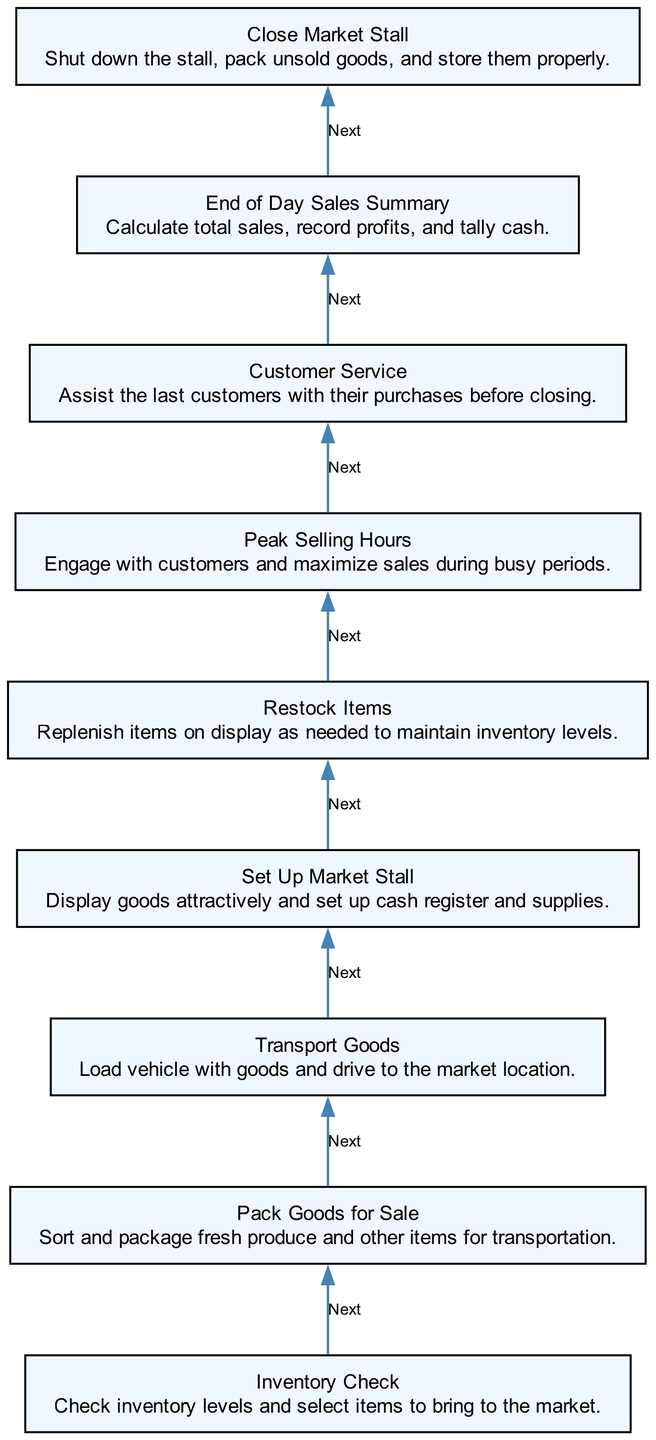What is the first step in the sales process? The flowchart indicates that the first step when starting the sales process is "Inventory Check," which involves checking inventory levels and selecting items to bring to the market.
Answer: Inventory Check How many steps are there in the process? By counting each listed step in the flowchart, there are a total of nine distinct steps involved in the weekend market sales process.
Answer: Nine What step comes after "Transport Goods"? The diagram shows that the step following "Transport Goods" is "Set Up Market Stall." It directly connects as the next action after loading goods for transport.
Answer: Set Up Market Stall Which step involves maximizing sales during busy periods? The step named "Peak Selling Hours" is specifically focused on engaging with customers to maximize sales during those busy times at the market.
Answer: Peak Selling Hours What happens immediately before "End of Day Sales Summary"? "Customer Service" precedes "End of Day Sales Summary," as indicated by the flow from one step to the next in the diagram.
Answer: Customer Service What is the last step in the weekend market sales process? The final step in the flowchart is "Close Market Stall," which refers to shutting down the stall and packing any unsold goods.
Answer: Close Market Stall What do you do after "Restock Items"? According to the flowchart, after "Restock Items," the next action is "Peak Selling Hours," indicating that replenishment is followed by the peak sales period.
Answer: Peak Selling Hours Which step includes packaging fresh produce for transportation? The step "Pack Goods for Sale" specifically mentions sorting and packaging fresh produce and other items before they are transported to the market.
Answer: Pack Goods for Sale How are the steps organized in the diagram? The steps are organized in a bottom-to-top flowchart format, where each step directs to the previous one chronologically as part of the sales process.
Answer: Bottom to top 